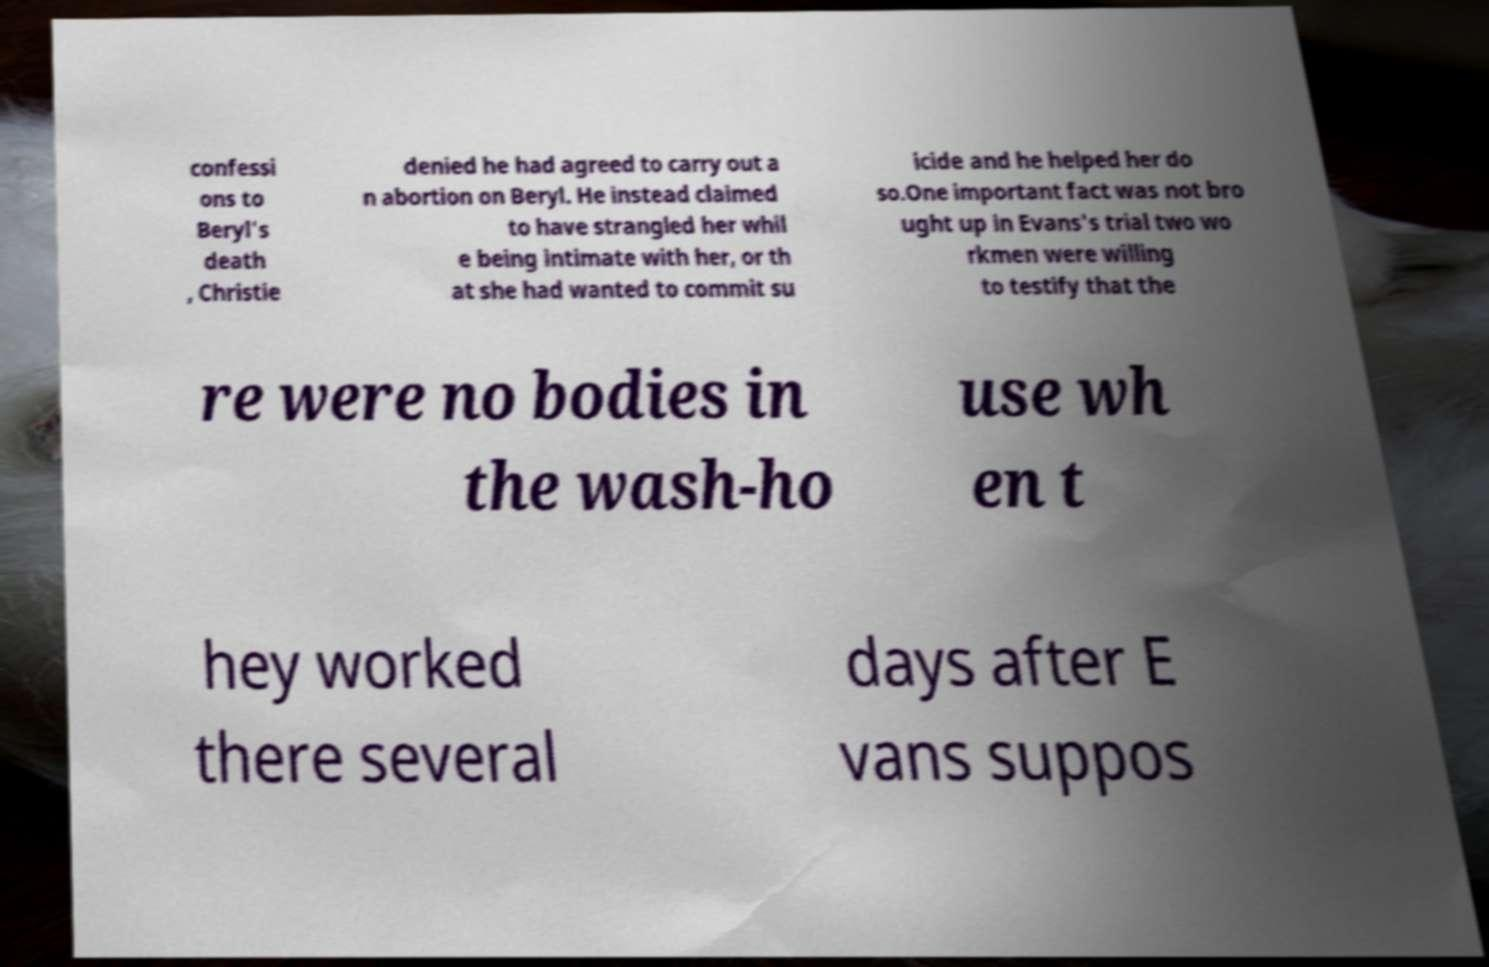Can you accurately transcribe the text from the provided image for me? confessi ons to Beryl's death , Christie denied he had agreed to carry out a n abortion on Beryl. He instead claimed to have strangled her whil e being intimate with her, or th at she had wanted to commit su icide and he helped her do so.One important fact was not bro ught up in Evans's trial two wo rkmen were willing to testify that the re were no bodies in the wash-ho use wh en t hey worked there several days after E vans suppos 